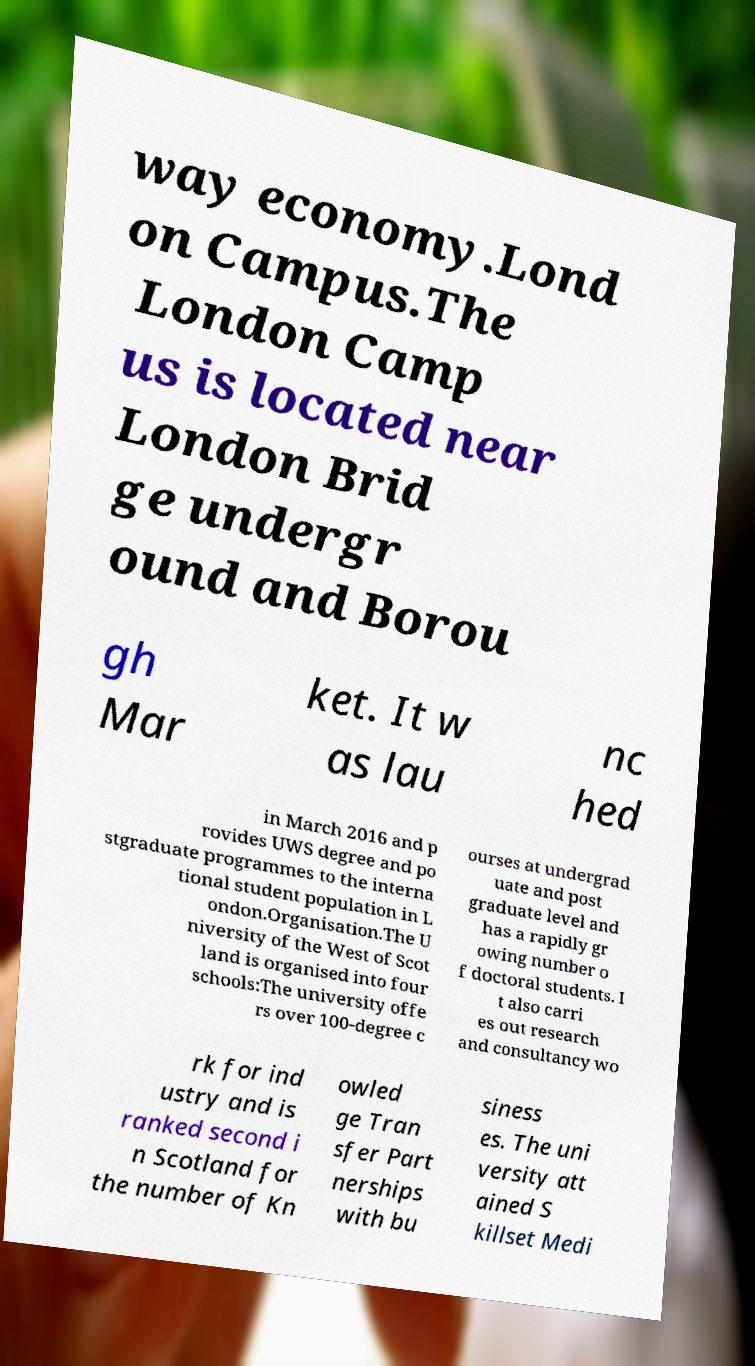Could you extract and type out the text from this image? way economy.Lond on Campus.The London Camp us is located near London Brid ge undergr ound and Borou gh Mar ket. It w as lau nc hed in March 2016 and p rovides UWS degree and po stgraduate programmes to the interna tional student population in L ondon.Organisation.The U niversity of the West of Scot land is organised into four schools:The university offe rs over 100-degree c ourses at undergrad uate and post graduate level and has a rapidly gr owing number o f doctoral students. I t also carri es out research and consultancy wo rk for ind ustry and is ranked second i n Scotland for the number of Kn owled ge Tran sfer Part nerships with bu siness es. The uni versity att ained S killset Medi 